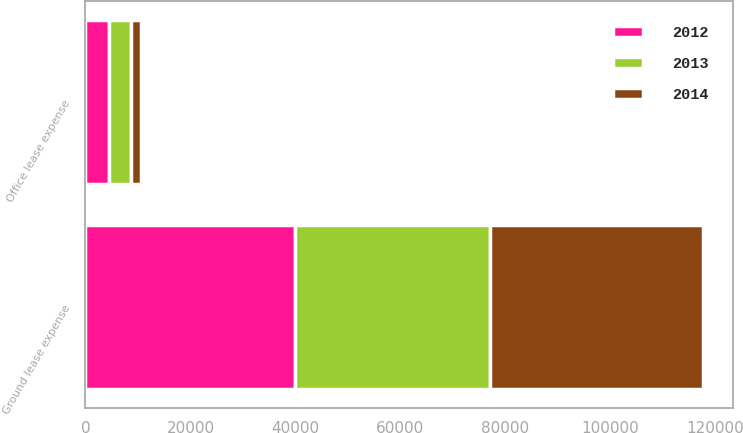Convert chart to OTSL. <chart><loc_0><loc_0><loc_500><loc_500><stacked_bar_chart><ecel><fcel>Ground lease expense<fcel>Office lease expense<nl><fcel>2012<fcel>39898<fcel>4577<nl><fcel>2013<fcel>37150<fcel>4057<nl><fcel>2014<fcel>40518<fcel>2004<nl></chart> 